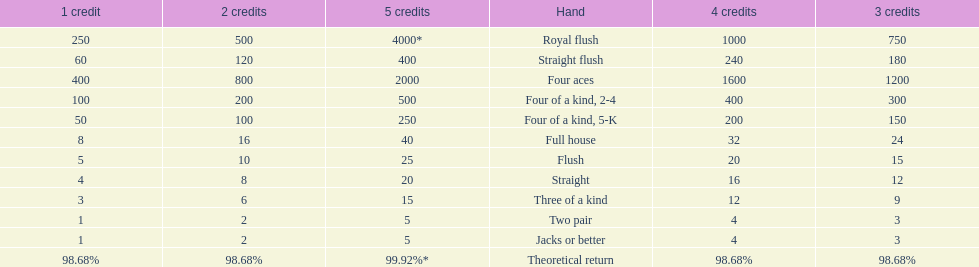Could you help me parse every detail presented in this table? {'header': ['1 credit', '2 credits', '5 credits', 'Hand', '4 credits', '3 credits'], 'rows': [['250', '500', '4000*', 'Royal flush', '1000', '750'], ['60', '120', '400', 'Straight flush', '240', '180'], ['400', '800', '2000', 'Four aces', '1600', '1200'], ['100', '200', '500', 'Four of a kind, 2-4', '400', '300'], ['50', '100', '250', 'Four of a kind, 5-K', '200', '150'], ['8', '16', '40', 'Full house', '32', '24'], ['5', '10', '25', 'Flush', '20', '15'], ['4', '8', '20', 'Straight', '16', '12'], ['3', '6', '15', 'Three of a kind', '12', '9'], ['1', '2', '5', 'Two pair', '4', '3'], ['1', '2', '5', 'Jacks or better', '4', '3'], ['98.68%', '98.68%', '99.92%*', 'Theoretical return', '98.68%', '98.68%']]} Is a 2 credit full house the same as a 5 credit three of a kind? No. 